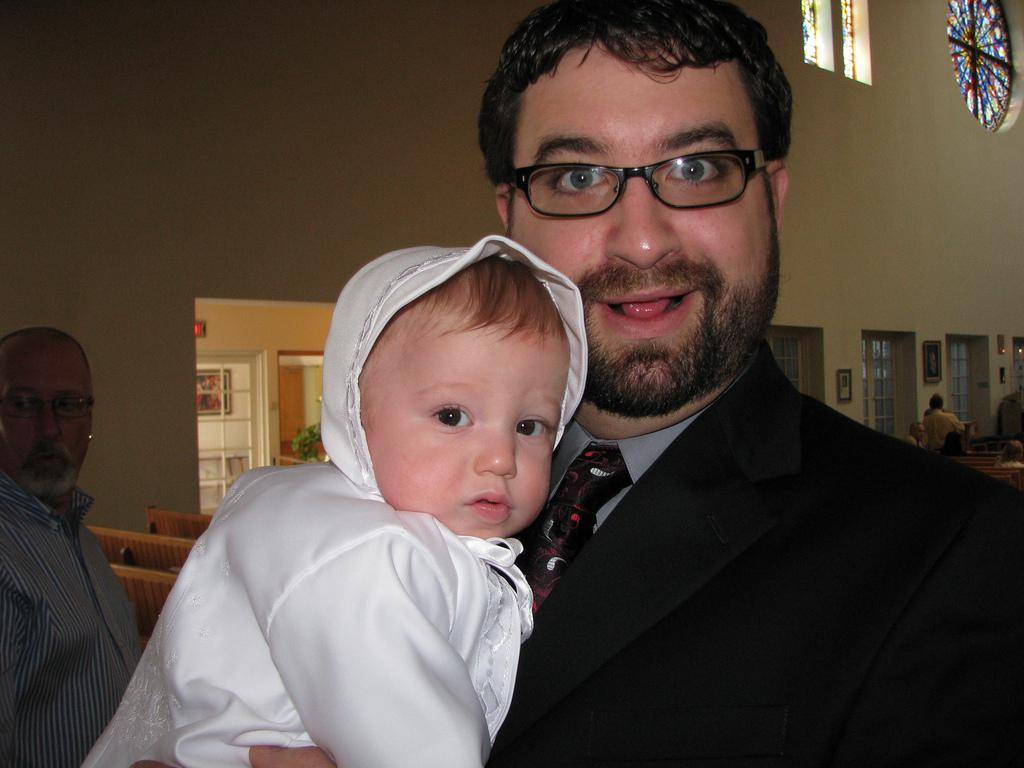Question: who has beard and mustache?
Choices:
A. Grandfather.
B. Man.
C. Uncle.
D. Brother.
Answer with the letter. Answer: B Question: who is wearing dark-rimmed glasses?
Choices:
A. Woman.
B. Child.
C. Librarian.
D. Man.
Answer with the letter. Answer: D Question: what is man holding?
Choices:
A. Baby.
B. Bag.
C. Book.
D. Dog.
Answer with the letter. Answer: A Question: who has facial hair?
Choices:
A. Teenage.
B. Man.
C. Woman.
D. Lumberjack.
Answer with the letter. Answer: B Question: what color is the baby's hat?
Choices:
A. White.
B. Blue.
C. Pink.
D. Yellow.
Answer with the letter. Answer: A Question: what does the man have on his face?
Choices:
A. Beard.
B. Mole.
C. Glasses.
D. Mustache.
Answer with the letter. Answer: C Question: what color is the man's shirt?
Choices:
A. Blue.
B. Orange.
C. White.
D. Gray.
Answer with the letter. Answer: D Question: who is holding the baby?
Choices:
A. A woman.
B. A man.
C. A Child.
D. No one.
Answer with the letter. Answer: B Question: where are the man and his child?
Choices:
A. School.
B. Store.
C. Playground.
D. Church.
Answer with the letter. Answer: D Question: what kind of glass are the windows?
Choices:
A. Stained.
B. Tempered.
C. Clear.
D. Bulletproof.
Answer with the letter. Answer: A Question: what is the man in the background wearing?
Choices:
A. A striped shirt.
B. A black shirt.
C. A suit and tie.
D. A white shirt.
Answer with the letter. Answer: A Question: what design is on the man's tie?
Choices:
A. Black white white and green.
B. Black with silver and red.
C. Blue with silver and red.
D. White with red and green.
Answer with the letter. Answer: B Question: what color is the baby wearing?
Choices:
A. White.
B. Pink.
C. Blue.
D. Yellow.
Answer with the letter. Answer: A Question: how many people have on glasses?
Choices:
A. Three.
B. Four.
C. None.
D. Two.
Answer with the letter. Answer: D Question: who is looking into the camera?
Choices:
A. The girl.
B. The boy.
C. The man and baby.
D. The woman.
Answer with the letter. Answer: C 